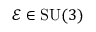<formula> <loc_0><loc_0><loc_500><loc_500>\mathcal { E } \in S U ( 3 )</formula> 